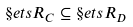Convert formula to latex. <formula><loc_0><loc_0><loc_500><loc_500>\S e t s R _ { C } \subseteq \S e t s R _ { D }</formula> 